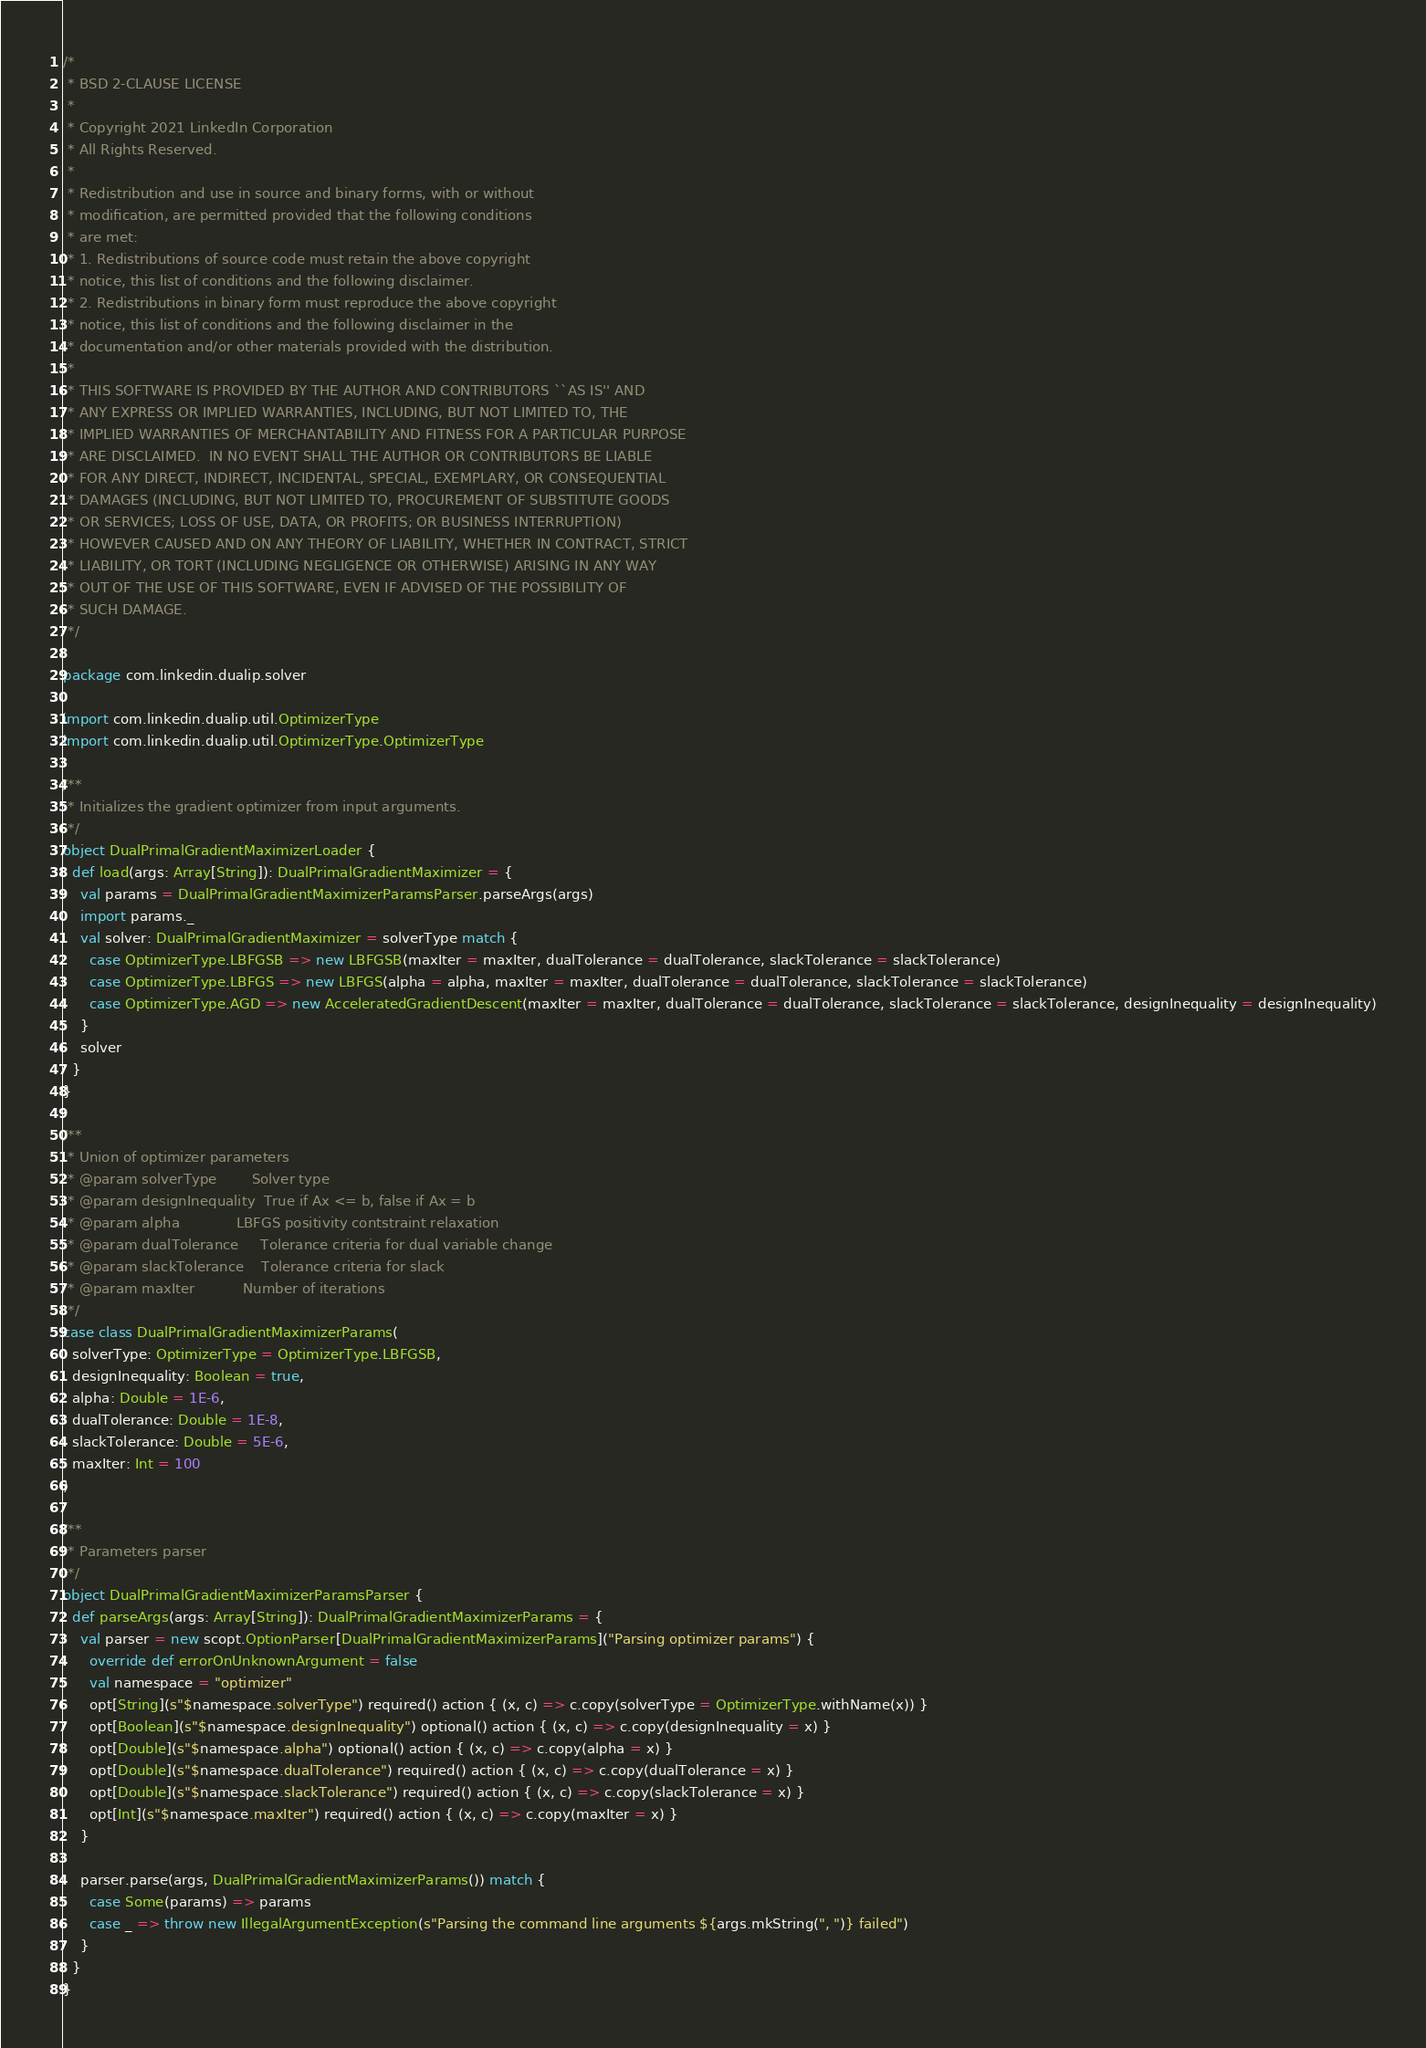<code> <loc_0><loc_0><loc_500><loc_500><_Scala_>/*
 * BSD 2-CLAUSE LICENSE
 *
 * Copyright 2021 LinkedIn Corporation
 * All Rights Reserved.
 *
 * Redistribution and use in source and binary forms, with or without
 * modification, are permitted provided that the following conditions
 * are met:
 * 1. Redistributions of source code must retain the above copyright
 * notice, this list of conditions and the following disclaimer.
 * 2. Redistributions in binary form must reproduce the above copyright
 * notice, this list of conditions and the following disclaimer in the
 * documentation and/or other materials provided with the distribution.
 *
 * THIS SOFTWARE IS PROVIDED BY THE AUTHOR AND CONTRIBUTORS ``AS IS'' AND
 * ANY EXPRESS OR IMPLIED WARRANTIES, INCLUDING, BUT NOT LIMITED TO, THE
 * IMPLIED WARRANTIES OF MERCHANTABILITY AND FITNESS FOR A PARTICULAR PURPOSE
 * ARE DISCLAIMED.  IN NO EVENT SHALL THE AUTHOR OR CONTRIBUTORS BE LIABLE
 * FOR ANY DIRECT, INDIRECT, INCIDENTAL, SPECIAL, EXEMPLARY, OR CONSEQUENTIAL
 * DAMAGES (INCLUDING, BUT NOT LIMITED TO, PROCUREMENT OF SUBSTITUTE GOODS
 * OR SERVICES; LOSS OF USE, DATA, OR PROFITS; OR BUSINESS INTERRUPTION)
 * HOWEVER CAUSED AND ON ANY THEORY OF LIABILITY, WHETHER IN CONTRACT, STRICT
 * LIABILITY, OR TORT (INCLUDING NEGLIGENCE OR OTHERWISE) ARISING IN ANY WAY
 * OUT OF THE USE OF THIS SOFTWARE, EVEN IF ADVISED OF THE POSSIBILITY OF
 * SUCH DAMAGE.
 */
 
package com.linkedin.dualip.solver

import com.linkedin.dualip.util.OptimizerType
import com.linkedin.dualip.util.OptimizerType.OptimizerType

/**
 * Initializes the gradient optimizer from input arguments.
 */
object DualPrimalGradientMaximizerLoader {
  def load(args: Array[String]): DualPrimalGradientMaximizer = {
    val params = DualPrimalGradientMaximizerParamsParser.parseArgs(args)
    import params._
    val solver: DualPrimalGradientMaximizer = solverType match {
      case OptimizerType.LBFGSB => new LBFGSB(maxIter = maxIter, dualTolerance = dualTolerance, slackTolerance = slackTolerance)
      case OptimizerType.LBFGS => new LBFGS(alpha = alpha, maxIter = maxIter, dualTolerance = dualTolerance, slackTolerance = slackTolerance)
      case OptimizerType.AGD => new AcceleratedGradientDescent(maxIter = maxIter, dualTolerance = dualTolerance, slackTolerance = slackTolerance, designInequality = designInequality)
    }
    solver
  }
}

/**
 * Union of optimizer parameters
 * @param solverType        Solver type
 * @param designInequality  True if Ax <= b, false if Ax = b
 * @param alpha             LBFGS positivity contstraint relaxation
 * @param dualTolerance     Tolerance criteria for dual variable change
 * @param slackTolerance    Tolerance criteria for slack
 * @param maxIter           Number of iterations
 */
case class DualPrimalGradientMaximizerParams(
  solverType: OptimizerType = OptimizerType.LBFGSB,
  designInequality: Boolean = true,
  alpha: Double = 1E-6,
  dualTolerance: Double = 1E-8,
  slackTolerance: Double = 5E-6,
  maxIter: Int = 100
)

/**
 * Parameters parser
 */
object DualPrimalGradientMaximizerParamsParser {
  def parseArgs(args: Array[String]): DualPrimalGradientMaximizerParams = {
    val parser = new scopt.OptionParser[DualPrimalGradientMaximizerParams]("Parsing optimizer params") {
      override def errorOnUnknownArgument = false
      val namespace = "optimizer"
      opt[String](s"$namespace.solverType") required() action { (x, c) => c.copy(solverType = OptimizerType.withName(x)) }
      opt[Boolean](s"$namespace.designInequality") optional() action { (x, c) => c.copy(designInequality = x) }
      opt[Double](s"$namespace.alpha") optional() action { (x, c) => c.copy(alpha = x) }
      opt[Double](s"$namespace.dualTolerance") required() action { (x, c) => c.copy(dualTolerance = x) }
      opt[Double](s"$namespace.slackTolerance") required() action { (x, c) => c.copy(slackTolerance = x) }
      opt[Int](s"$namespace.maxIter") required() action { (x, c) => c.copy(maxIter = x) }
    }

    parser.parse(args, DualPrimalGradientMaximizerParams()) match {
      case Some(params) => params
      case _ => throw new IllegalArgumentException(s"Parsing the command line arguments ${args.mkString(", ")} failed")
    }
  }
}</code> 